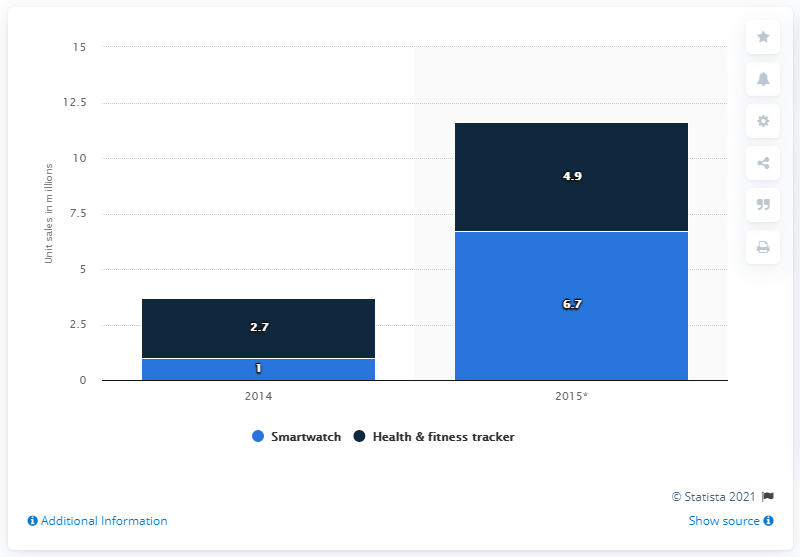Identify some key points in this picture. The forecast for the sale of smartwatches in Asia Pacific in 2015 is 6.7 units. 